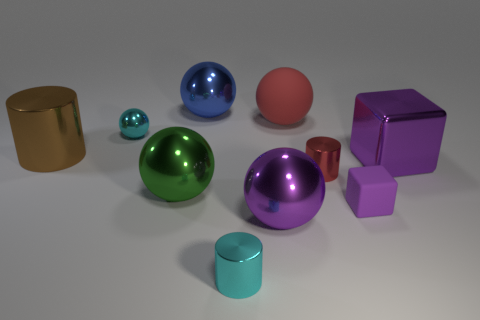Subtract all small cyan spheres. How many spheres are left? 4 Subtract all purple balls. How many balls are left? 4 Subtract 2 spheres. How many spheres are left? 3 Subtract all gray cubes. How many red cylinders are left? 1 Subtract all green things. Subtract all tiny cubes. How many objects are left? 8 Add 8 large green metal things. How many large green metal things are left? 9 Add 2 rubber objects. How many rubber objects exist? 4 Subtract 1 blue spheres. How many objects are left? 9 Subtract all cylinders. How many objects are left? 7 Subtract all cyan cylinders. Subtract all blue balls. How many cylinders are left? 2 